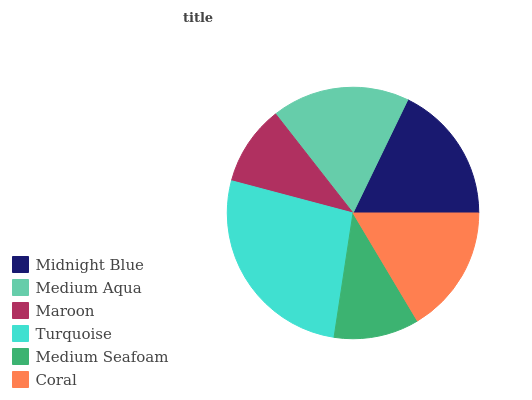Is Maroon the minimum?
Answer yes or no. Yes. Is Turquoise the maximum?
Answer yes or no. Yes. Is Medium Aqua the minimum?
Answer yes or no. No. Is Medium Aqua the maximum?
Answer yes or no. No. Is Midnight Blue greater than Medium Aqua?
Answer yes or no. Yes. Is Medium Aqua less than Midnight Blue?
Answer yes or no. Yes. Is Medium Aqua greater than Midnight Blue?
Answer yes or no. No. Is Midnight Blue less than Medium Aqua?
Answer yes or no. No. Is Medium Aqua the high median?
Answer yes or no. Yes. Is Coral the low median?
Answer yes or no. Yes. Is Medium Seafoam the high median?
Answer yes or no. No. Is Medium Seafoam the low median?
Answer yes or no. No. 